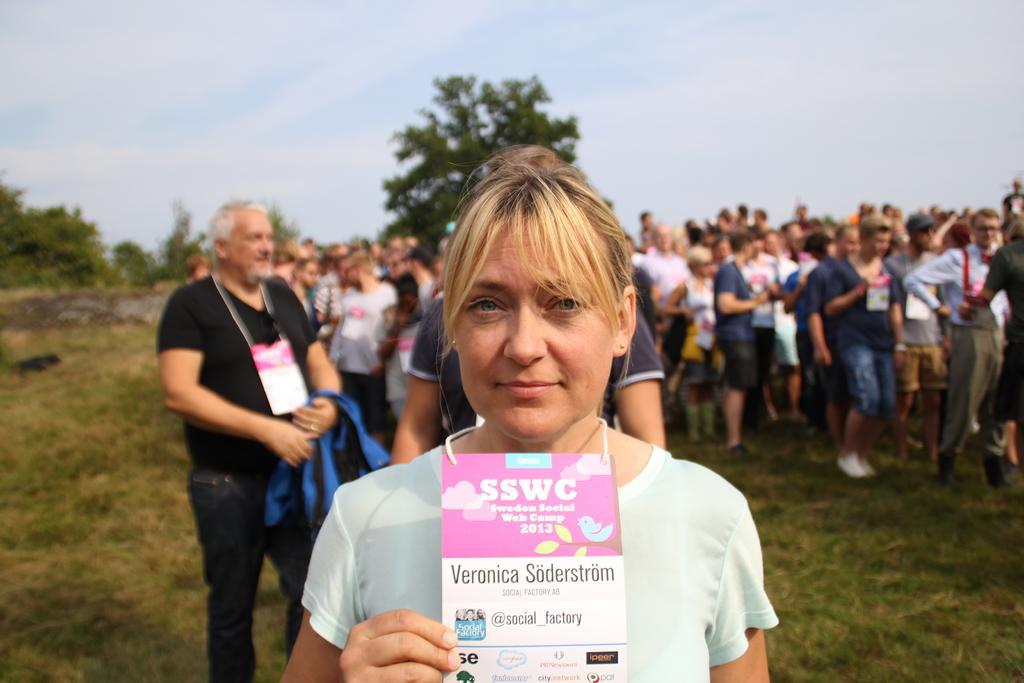In one or two sentences, can you explain what this image depicts? In this image, there are a few people. Among them, we can see a lady holding an object. We can see the ground. We can see some grass and trees. We can also see the sky. 